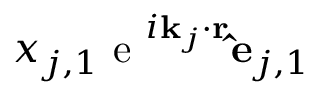Convert formula to latex. <formula><loc_0><loc_0><loc_500><loc_500>x _ { j , 1 } e ^ { i k _ { j } \cdot r } \hat { e } _ { j , 1 }</formula> 